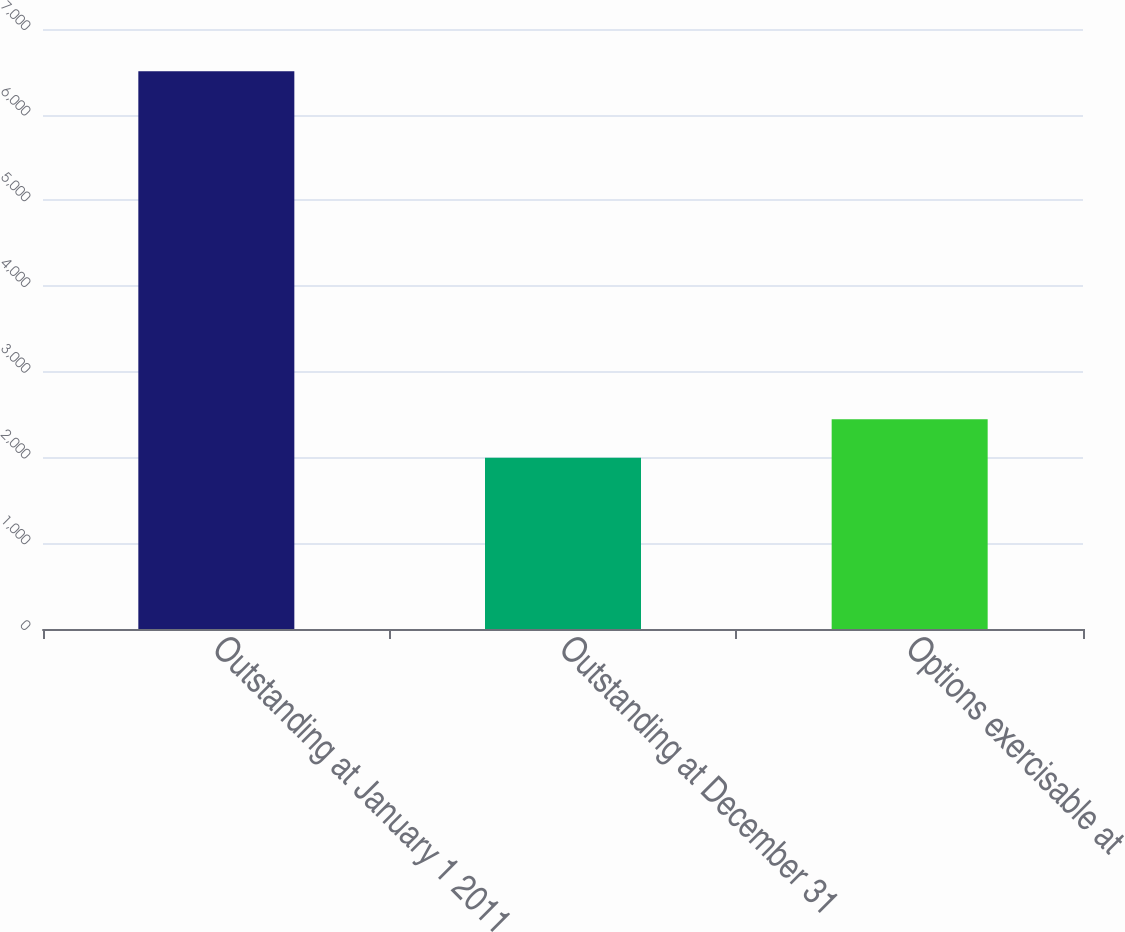Convert chart. <chart><loc_0><loc_0><loc_500><loc_500><bar_chart><fcel>Outstanding at January 1 2011<fcel>Outstanding at December 31<fcel>Options exercisable at<nl><fcel>6506<fcel>1997<fcel>2447.9<nl></chart> 